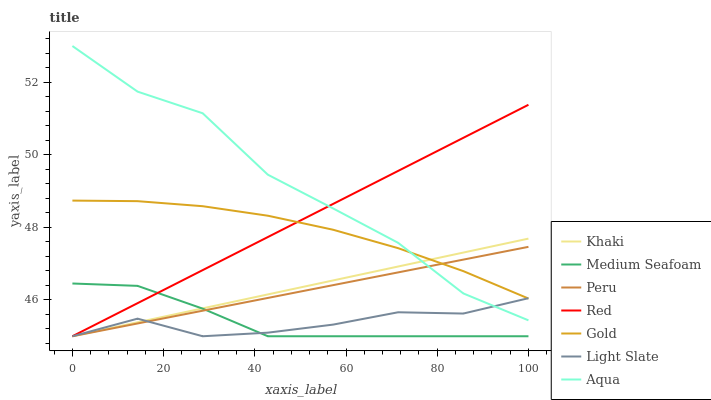Does Light Slate have the minimum area under the curve?
Answer yes or no. Yes. Does Aqua have the maximum area under the curve?
Answer yes or no. Yes. Does Gold have the minimum area under the curve?
Answer yes or no. No. Does Gold have the maximum area under the curve?
Answer yes or no. No. Is Peru the smoothest?
Answer yes or no. Yes. Is Aqua the roughest?
Answer yes or no. Yes. Is Gold the smoothest?
Answer yes or no. No. Is Gold the roughest?
Answer yes or no. No. Does Khaki have the lowest value?
Answer yes or no. Yes. Does Gold have the lowest value?
Answer yes or no. No. Does Aqua have the highest value?
Answer yes or no. Yes. Does Gold have the highest value?
Answer yes or no. No. Is Medium Seafoam less than Aqua?
Answer yes or no. Yes. Is Gold greater than Medium Seafoam?
Answer yes or no. Yes. Does Khaki intersect Peru?
Answer yes or no. Yes. Is Khaki less than Peru?
Answer yes or no. No. Is Khaki greater than Peru?
Answer yes or no. No. Does Medium Seafoam intersect Aqua?
Answer yes or no. No. 